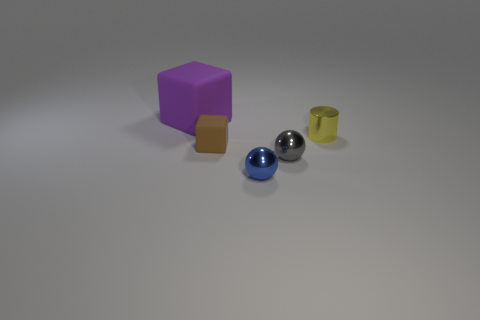What materials do the objects in the image appear to be made of? The objects in the image seem to be made of different materials; the cubes might be made of plastic or wood. One sphere appears shiny and metallic, while the other might be glass or a highly polished stone. The cylindrical item might be made of either metal or plastic. 